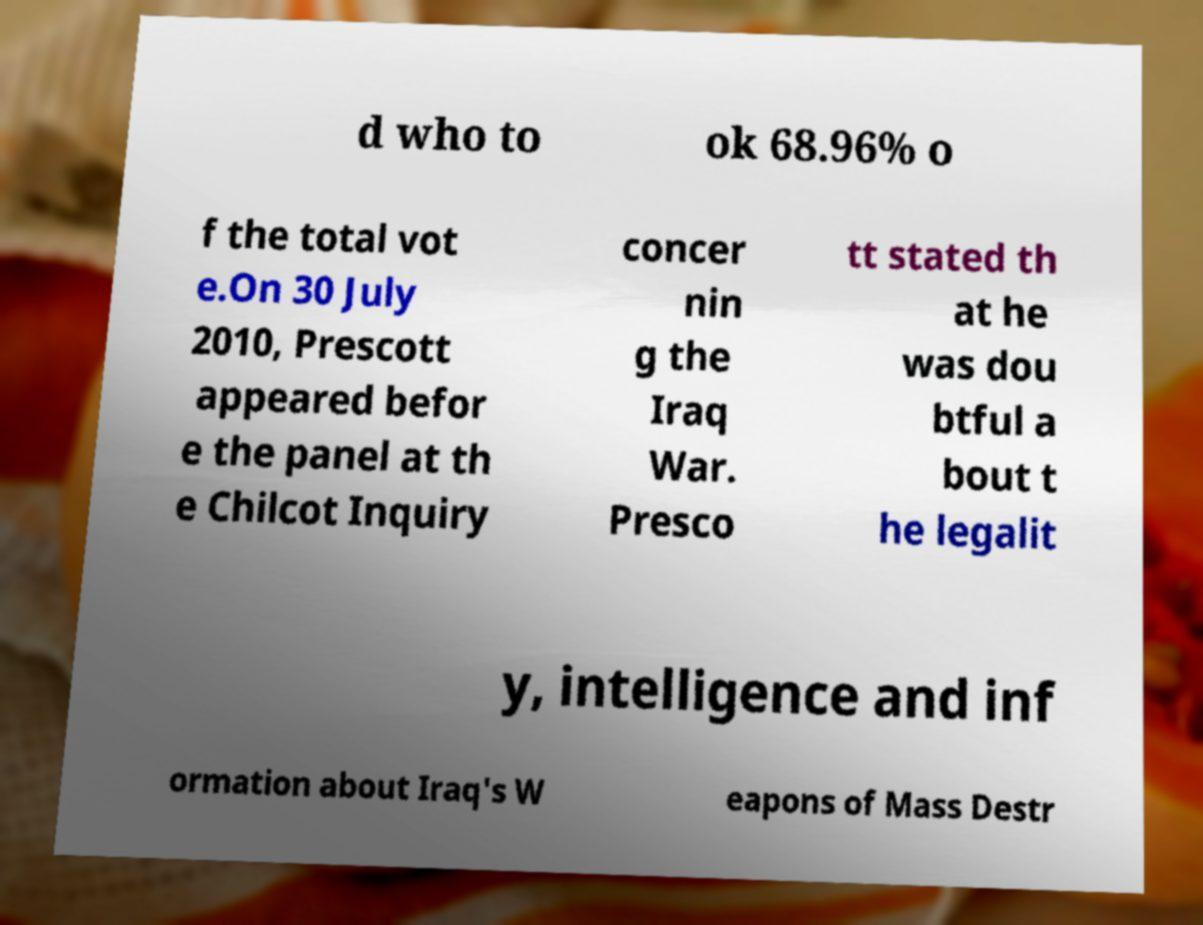Can you read and provide the text displayed in the image?This photo seems to have some interesting text. Can you extract and type it out for me? d who to ok 68.96% o f the total vot e.On 30 July 2010, Prescott appeared befor e the panel at th e Chilcot Inquiry concer nin g the Iraq War. Presco tt stated th at he was dou btful a bout t he legalit y, intelligence and inf ormation about Iraq's W eapons of Mass Destr 